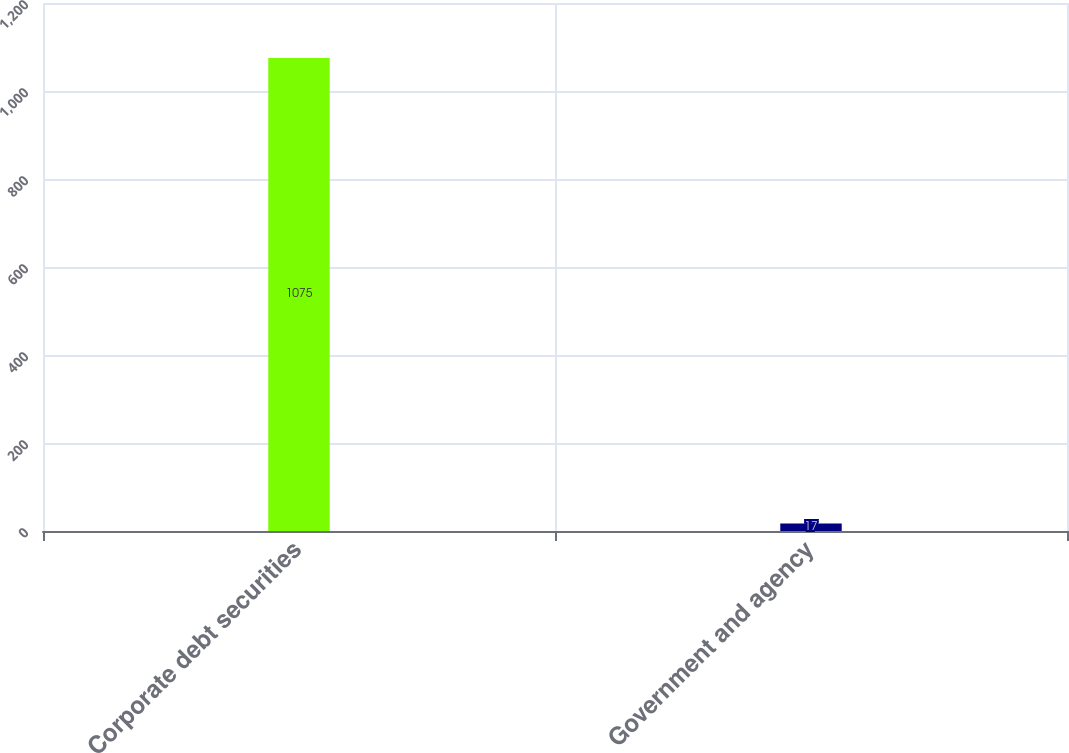Convert chart. <chart><loc_0><loc_0><loc_500><loc_500><bar_chart><fcel>Corporate debt securities<fcel>Government and agency<nl><fcel>1075<fcel>17<nl></chart> 